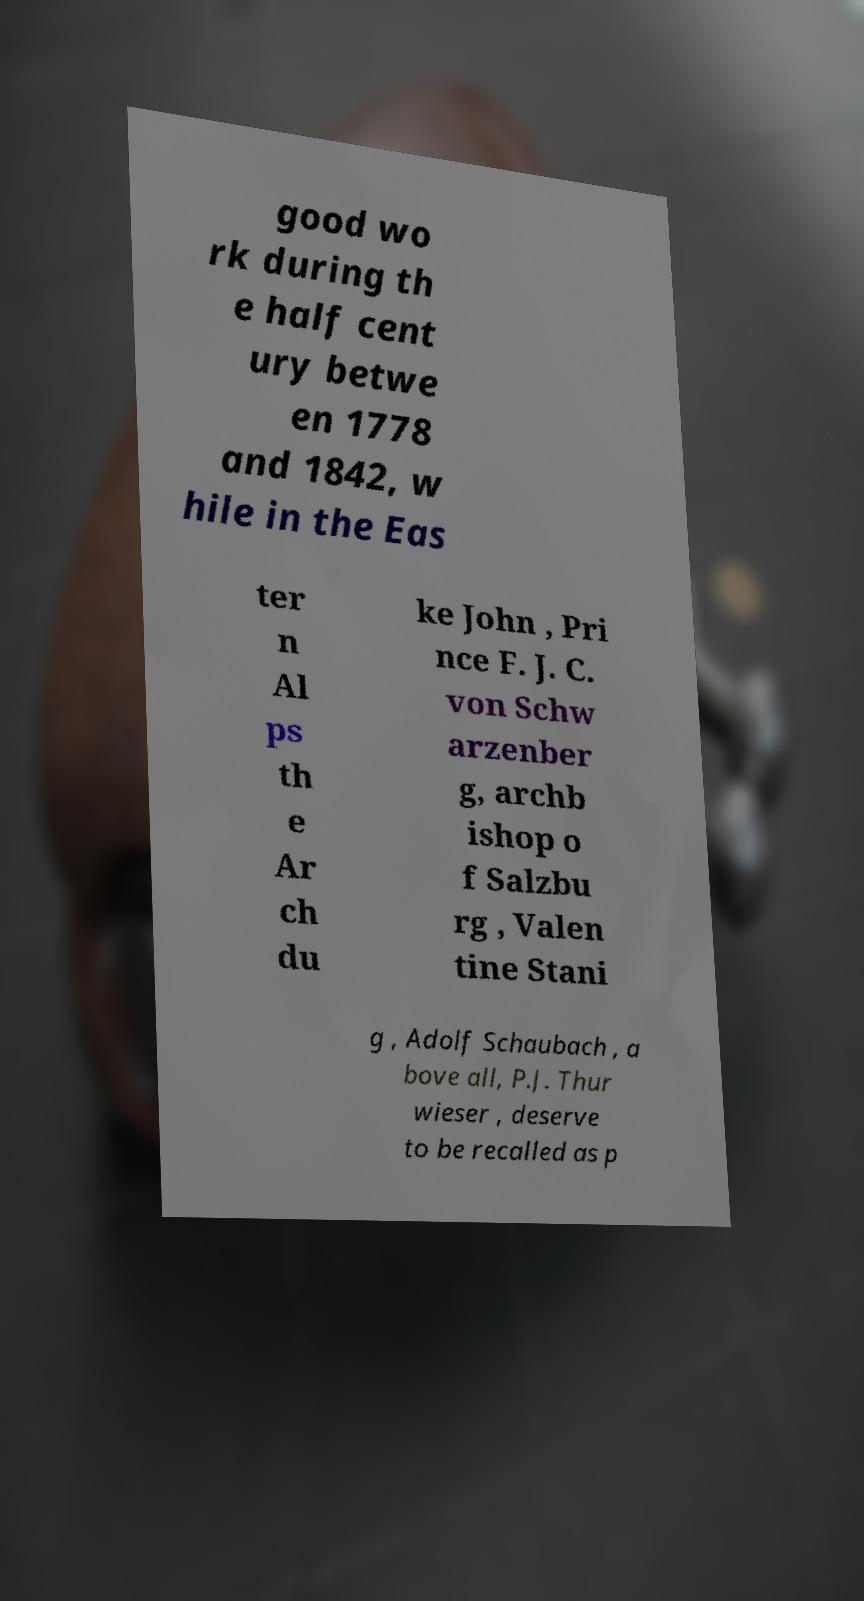I need the written content from this picture converted into text. Can you do that? good wo rk during th e half cent ury betwe en 1778 and 1842, w hile in the Eas ter n Al ps th e Ar ch du ke John , Pri nce F. J. C. von Schw arzenber g, archb ishop o f Salzbu rg , Valen tine Stani g , Adolf Schaubach , a bove all, P.J. Thur wieser , deserve to be recalled as p 